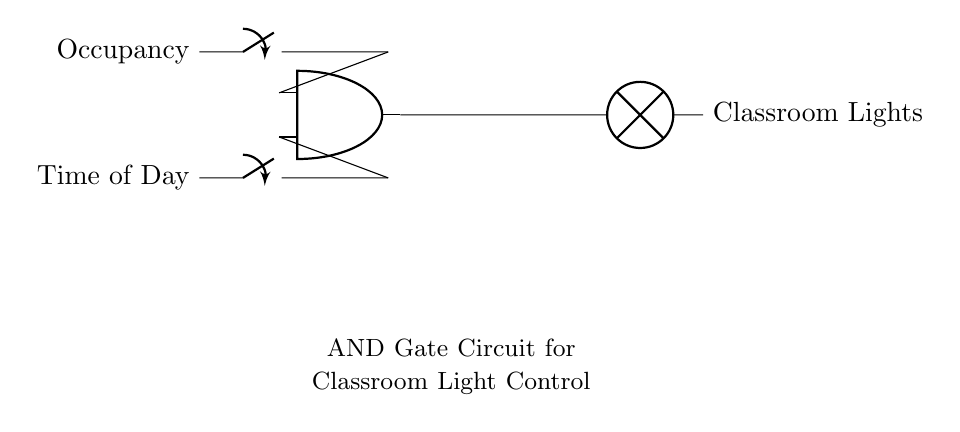What are the two inputs for the AND gate? The two inputs are labeled as "Occupancy" and "Time of Day," which are both represented as switches in the circuit diagram.
Answer: Occupancy, Time of Day What does the output represent in this circuit? The output from the AND gate leads to a lamp, which represents the "Classroom Lights." This indicates that the lights are controlled based on the inputs.
Answer: Classroom Lights If one switch is off, what will be the output? In an AND gate, if one input is off (or low), the output will also be off because both inputs must be on for the output to be on.
Answer: Off What is the purpose of the AND gate in this circuit? The AND gate serves to ensure that the classroom lights are turned on only when both conditions (occupancy detected and appropriate time of day) are met.
Answer: Control lights based on conditions What condition must both inputs satisfy to turn on the classroom lights? Both inputs, "Occupancy" and "Time of Day," must be in the on position for the output to turn on the classroom lights.
Answer: Both inputs must be on What type of circuit is used to control the lights based on the inputs? This circuit uses a logic gate, specifically an AND gate, to combine the two inputs and determine the state of the output.
Answer: Logic gate 